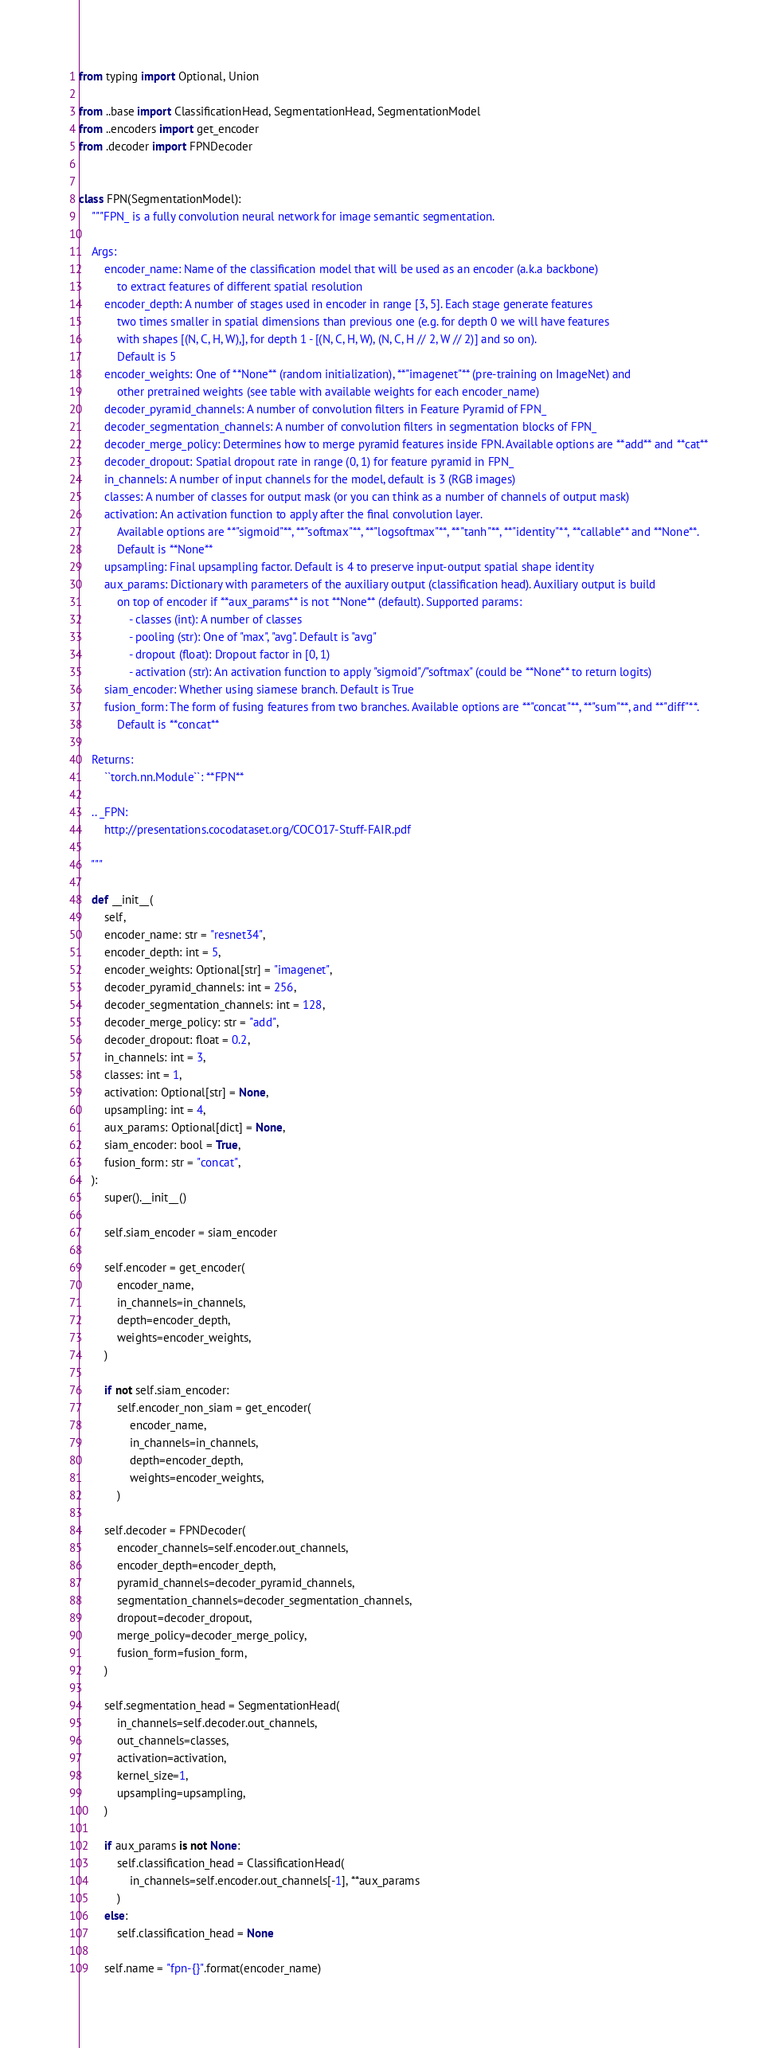Convert code to text. <code><loc_0><loc_0><loc_500><loc_500><_Python_>from typing import Optional, Union

from ..base import ClassificationHead, SegmentationHead, SegmentationModel
from ..encoders import get_encoder
from .decoder import FPNDecoder


class FPN(SegmentationModel):
    """FPN_ is a fully convolution neural network for image semantic segmentation.

    Args:
        encoder_name: Name of the classification model that will be used as an encoder (a.k.a backbone)
            to extract features of different spatial resolution
        encoder_depth: A number of stages used in encoder in range [3, 5]. Each stage generate features 
            two times smaller in spatial dimensions than previous one (e.g. for depth 0 we will have features
            with shapes [(N, C, H, W),], for depth 1 - [(N, C, H, W), (N, C, H // 2, W // 2)] and so on).
            Default is 5
        encoder_weights: One of **None** (random initialization), **"imagenet"** (pre-training on ImageNet) and 
            other pretrained weights (see table with available weights for each encoder_name)
        decoder_pyramid_channels: A number of convolution filters in Feature Pyramid of FPN_
        decoder_segmentation_channels: A number of convolution filters in segmentation blocks of FPN_
        decoder_merge_policy: Determines how to merge pyramid features inside FPN. Available options are **add** and **cat**
        decoder_dropout: Spatial dropout rate in range (0, 1) for feature pyramid in FPN_
        in_channels: A number of input channels for the model, default is 3 (RGB images)
        classes: A number of classes for output mask (or you can think as a number of channels of output mask)
        activation: An activation function to apply after the final convolution layer.
            Available options are **"sigmoid"**, **"softmax"**, **"logsoftmax"**, **"tanh"**, **"identity"**, **callable** and **None**.
            Default is **None**
        upsampling: Final upsampling factor. Default is 4 to preserve input-output spatial shape identity
        aux_params: Dictionary with parameters of the auxiliary output (classification head). Auxiliary output is build 
            on top of encoder if **aux_params** is not **None** (default). Supported params:
                - classes (int): A number of classes
                - pooling (str): One of "max", "avg". Default is "avg"
                - dropout (float): Dropout factor in [0, 1)
                - activation (str): An activation function to apply "sigmoid"/"softmax" (could be **None** to return logits)
        siam_encoder: Whether using siamese branch. Default is True
        fusion_form: The form of fusing features from two branches. Available options are **"concat"**, **"sum"**, and **"diff"**.
            Default is **concat**

    Returns:
        ``torch.nn.Module``: **FPN**

    .. _FPN:
        http://presentations.cocodataset.org/COCO17-Stuff-FAIR.pdf

    """

    def __init__(
        self,
        encoder_name: str = "resnet34",
        encoder_depth: int = 5,
        encoder_weights: Optional[str] = "imagenet",
        decoder_pyramid_channels: int = 256,
        decoder_segmentation_channels: int = 128,
        decoder_merge_policy: str = "add",
        decoder_dropout: float = 0.2,
        in_channels: int = 3,
        classes: int = 1,
        activation: Optional[str] = None,
        upsampling: int = 4,
        aux_params: Optional[dict] = None,
        siam_encoder: bool = True,
        fusion_form: str = "concat",
    ):
        super().__init__()

        self.siam_encoder = siam_encoder

        self.encoder = get_encoder(
            encoder_name,
            in_channels=in_channels,
            depth=encoder_depth,
            weights=encoder_weights,
        )

        if not self.siam_encoder:
            self.encoder_non_siam = get_encoder(
                encoder_name,
                in_channels=in_channels,
                depth=encoder_depth,
                weights=encoder_weights,
            )

        self.decoder = FPNDecoder(
            encoder_channels=self.encoder.out_channels,
            encoder_depth=encoder_depth,
            pyramid_channels=decoder_pyramid_channels,
            segmentation_channels=decoder_segmentation_channels,
            dropout=decoder_dropout,
            merge_policy=decoder_merge_policy,
            fusion_form=fusion_form,
        )

        self.segmentation_head = SegmentationHead(
            in_channels=self.decoder.out_channels,
            out_channels=classes,
            activation=activation,
            kernel_size=1,
            upsampling=upsampling,
        )

        if aux_params is not None:
            self.classification_head = ClassificationHead(
                in_channels=self.encoder.out_channels[-1], **aux_params
            )
        else:
            self.classification_head = None

        self.name = "fpn-{}".format(encoder_name)</code> 